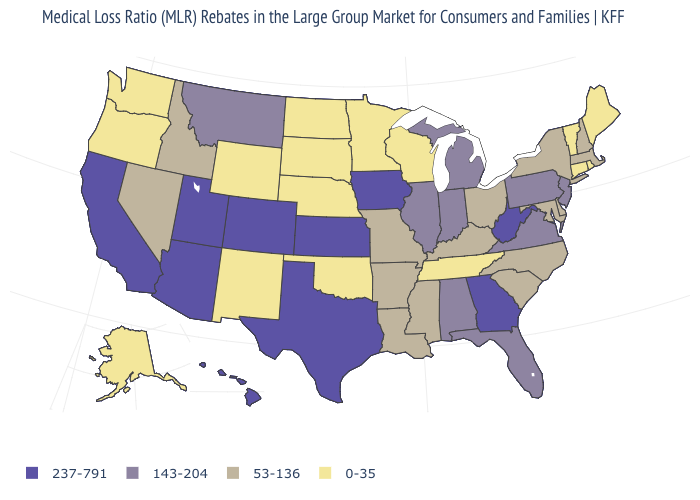What is the lowest value in the Northeast?
Write a very short answer. 0-35. What is the value of Colorado?
Write a very short answer. 237-791. Name the states that have a value in the range 0-35?
Give a very brief answer. Alaska, Connecticut, Maine, Minnesota, Nebraska, New Mexico, North Dakota, Oklahoma, Oregon, Rhode Island, South Dakota, Tennessee, Vermont, Washington, Wisconsin, Wyoming. What is the value of Virginia?
Answer briefly. 143-204. Which states hav the highest value in the MidWest?
Keep it brief. Iowa, Kansas. Does Iowa have the lowest value in the MidWest?
Be succinct. No. What is the value of South Dakota?
Short answer required. 0-35. Among the states that border Colorado , which have the highest value?
Write a very short answer. Arizona, Kansas, Utah. What is the value of Florida?
Be succinct. 143-204. What is the value of Vermont?
Keep it brief. 0-35. Name the states that have a value in the range 143-204?
Give a very brief answer. Alabama, Florida, Illinois, Indiana, Michigan, Montana, New Jersey, Pennsylvania, Virginia. Name the states that have a value in the range 0-35?
Be succinct. Alaska, Connecticut, Maine, Minnesota, Nebraska, New Mexico, North Dakota, Oklahoma, Oregon, Rhode Island, South Dakota, Tennessee, Vermont, Washington, Wisconsin, Wyoming. What is the value of Delaware?
Answer briefly. 53-136. Among the states that border Tennessee , does Virginia have the highest value?
Write a very short answer. No. Among the states that border Arkansas , which have the lowest value?
Answer briefly. Oklahoma, Tennessee. 